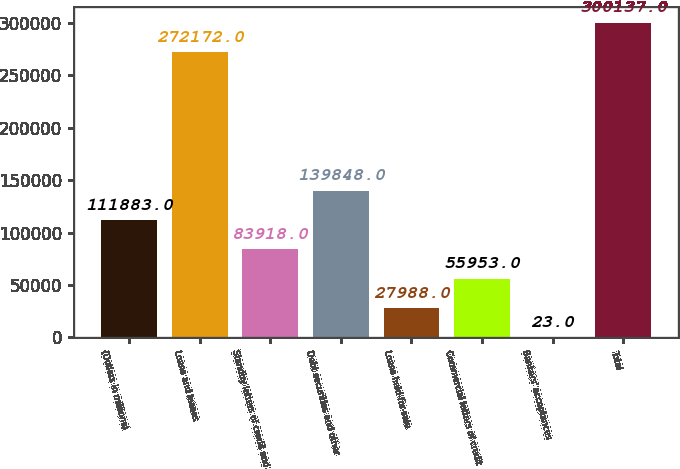Convert chart. <chart><loc_0><loc_0><loc_500><loc_500><bar_chart><fcel>(Dollars in millions)<fcel>Loans and leases<fcel>Standby letters of credit and<fcel>Debt securities and other<fcel>Loans held-for-sale<fcel>Commercial letters of credit<fcel>Bankers' acceptances<fcel>Total<nl><fcel>111883<fcel>272172<fcel>83918<fcel>139848<fcel>27988<fcel>55953<fcel>23<fcel>300137<nl></chart> 